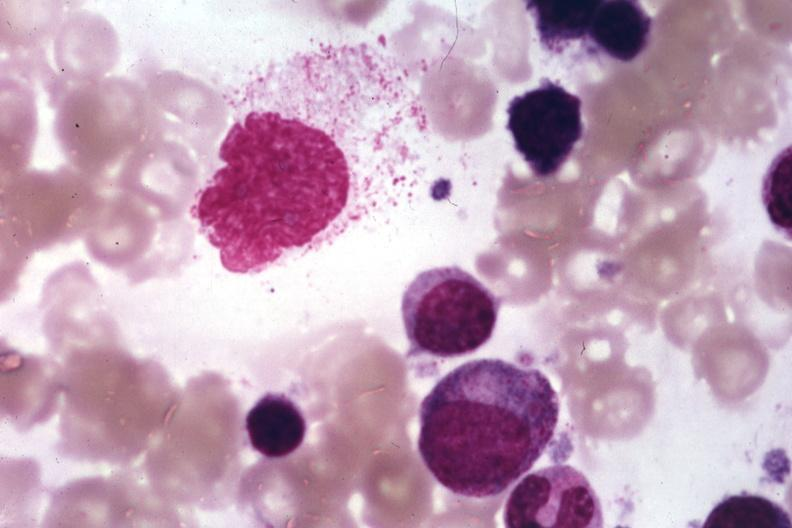what is present?
Answer the question using a single word or phrase. Bone marrow 